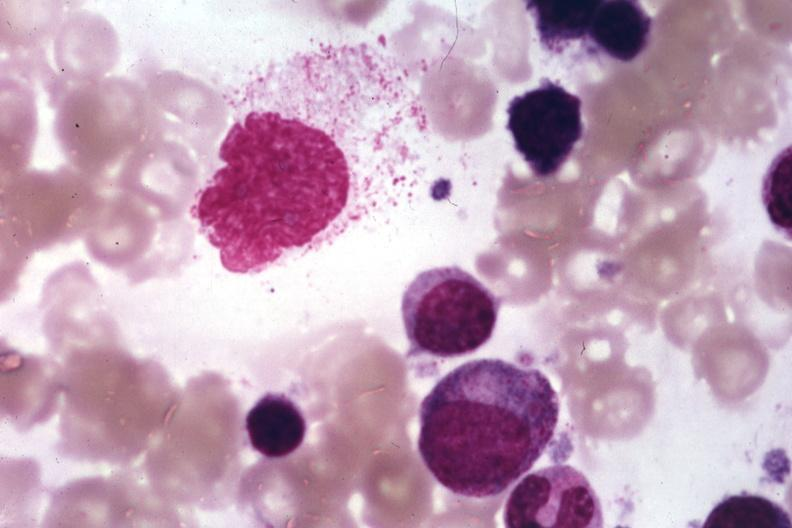what is present?
Answer the question using a single word or phrase. Bone marrow 